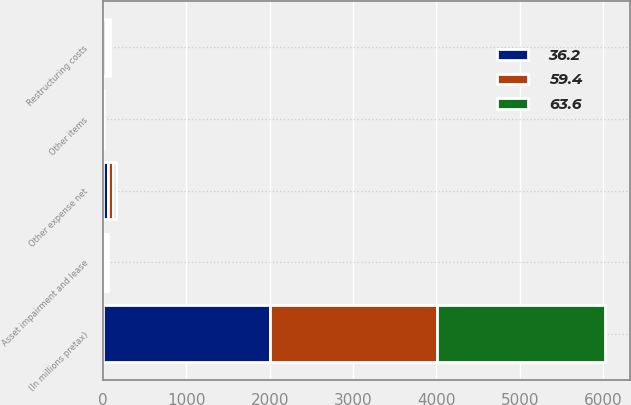Convert chart. <chart><loc_0><loc_0><loc_500><loc_500><stacked_bar_chart><ecel><fcel>(In millions pretax)<fcel>Restructuring costs<fcel>Asset impairment and lease<fcel>Other items<fcel>Other expense net<nl><fcel>59.4<fcel>2007<fcel>21.6<fcel>17.5<fcel>1.9<fcel>59.4<nl><fcel>63.6<fcel>2006<fcel>21.1<fcel>8.7<fcel>6.4<fcel>36.2<nl><fcel>36.2<fcel>2005<fcel>37.5<fcel>28.1<fcel>2<fcel>63.6<nl></chart> 